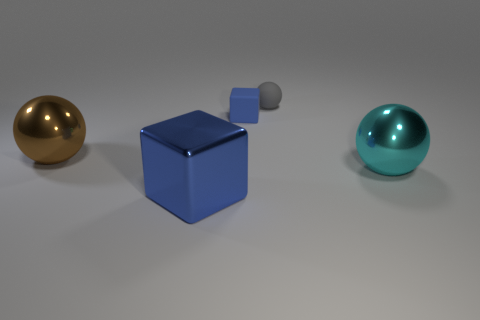Add 2 large blue shiny blocks. How many objects exist? 7 Subtract all blocks. How many objects are left? 3 Add 2 big gray matte blocks. How many big gray matte blocks exist? 2 Subtract 1 brown balls. How many objects are left? 4 Subtract all small purple rubber balls. Subtract all big spheres. How many objects are left? 3 Add 3 gray matte things. How many gray matte things are left? 4 